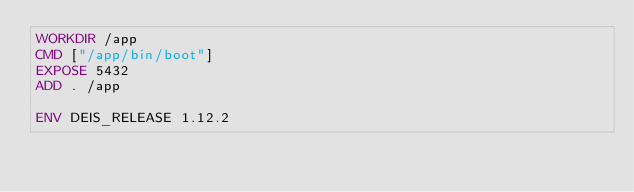<code> <loc_0><loc_0><loc_500><loc_500><_Dockerfile_>WORKDIR /app
CMD ["/app/bin/boot"]
EXPOSE 5432
ADD . /app

ENV DEIS_RELEASE 1.12.2
</code> 